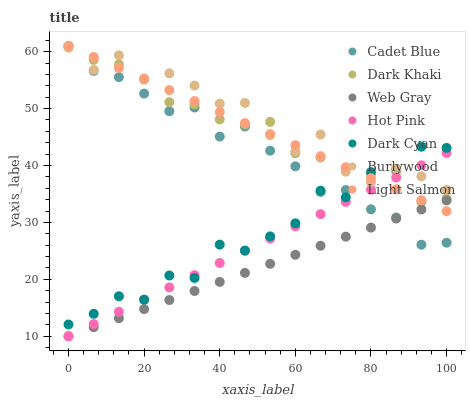Does Web Gray have the minimum area under the curve?
Answer yes or no. Yes. Does Burlywood have the maximum area under the curve?
Answer yes or no. Yes. Does Cadet Blue have the minimum area under the curve?
Answer yes or no. No. Does Cadet Blue have the maximum area under the curve?
Answer yes or no. No. Is Hot Pink the smoothest?
Answer yes or no. Yes. Is Burlywood the roughest?
Answer yes or no. Yes. Is Cadet Blue the smoothest?
Answer yes or no. No. Is Cadet Blue the roughest?
Answer yes or no. No. Does Hot Pink have the lowest value?
Answer yes or no. Yes. Does Cadet Blue have the lowest value?
Answer yes or no. No. Does Dark Khaki have the highest value?
Answer yes or no. Yes. Does Burlywood have the highest value?
Answer yes or no. No. Is Web Gray less than Dark Cyan?
Answer yes or no. Yes. Is Dark Khaki greater than Web Gray?
Answer yes or no. Yes. Does Light Salmon intersect Dark Khaki?
Answer yes or no. Yes. Is Light Salmon less than Dark Khaki?
Answer yes or no. No. Is Light Salmon greater than Dark Khaki?
Answer yes or no. No. Does Web Gray intersect Dark Cyan?
Answer yes or no. No. 